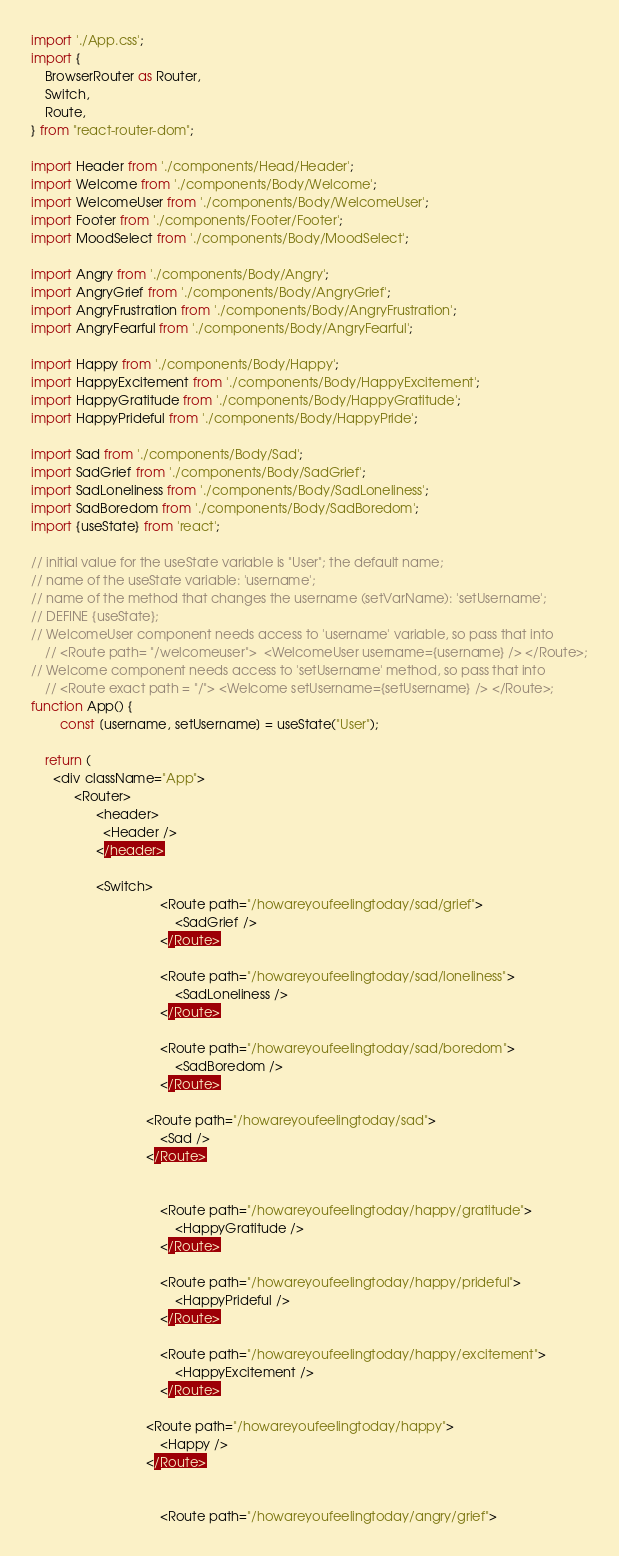<code> <loc_0><loc_0><loc_500><loc_500><_JavaScript_>import './App.css';
import {
    BrowserRouter as Router, 
    Switch,
    Route,
} from "react-router-dom";

import Header from './components/Head/Header';
import Welcome from './components/Body/Welcome';
import WelcomeUser from './components/Body/WelcomeUser';
import Footer from './components/Footer/Footer';
import MoodSelect from './components/Body/MoodSelect';

import Angry from './components/Body/Angry';
import AngryGrief from './components/Body/AngryGrief';
import AngryFrustration from './components/Body/AngryFrustration';
import AngryFearful from './components/Body/AngryFearful';

import Happy from './components/Body/Happy';
import HappyExcitement from './components/Body/HappyExcitement';
import HappyGratitude from './components/Body/HappyGratitude';
import HappyPrideful from './components/Body/HappyPride';

import Sad from './components/Body/Sad';
import SadGrief from './components/Body/SadGrief';
import SadLoneliness from './components/Body/SadLoneliness';
import SadBoredom from './components/Body/SadBoredom';
import {useState} from 'react';

// initial value for the useState variable is "User"; the default name;
// name of the useState variable: 'username';
// name of the method that changes the username (setVarName): 'setUsername';
// DEFINE {useState};
// WelcomeUser component needs access to 'username' variable, so pass that into
	// <Route path= "/welcomeuser">  <WelcomeUser username={username} /> </Route>;
// Welcome component needs access to 'setUsername' method, so pass that into
	// <Route exact path = "/"> <Welcome setUsername={setUsername} /> </Route>;
function App() {
		const [username, setUsername] = useState("User");

    return (
      <div className="App">
            <Router>
                  <header> 
                    <Header />
                  </header>
     							
                  <Switch>
									<Route path="/howareyoufeelingtoday/sad/grief">
										<SadGrief />
									</Route>

									<Route path="/howareyoufeelingtoday/sad/loneliness">
										<SadLoneliness />
									</Route>
									
									<Route path="/howareyoufeelingtoday/sad/boredom">
										<SadBoredom />
									</Route>

								<Route path="/howareyoufeelingtoday/sad"> 
									<Sad />
								</Route>
									

									<Route path="/howareyoufeelingtoday/happy/gratitude">
										<HappyGratitude />
									</Route>

									<Route path="/howareyoufeelingtoday/happy/prideful">
										<HappyPrideful />
									</Route>

									<Route path="/howareyoufeelingtoday/happy/excitement">
										<HappyExcitement />
									</Route>

								<Route path="/howareyoufeelingtoday/happy"> 
									<Happy />
								</Route>

								
									<Route path="/howareyoufeelingtoday/angry/grief"></code> 